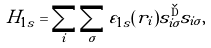<formula> <loc_0><loc_0><loc_500><loc_500>H _ { 1 s } = \sum _ { i } \sum _ { \sigma } \varepsilon _ { 1 s } ( { r } _ { i } ) s _ { i \sigma } ^ { \dag } s _ { i \sigma } ,</formula> 